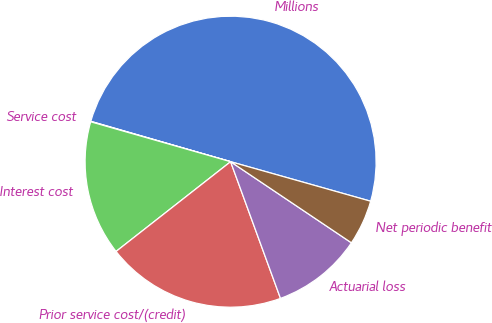<chart> <loc_0><loc_0><loc_500><loc_500><pie_chart><fcel>Millions<fcel>Service cost<fcel>Interest cost<fcel>Prior service cost/(credit)<fcel>Actuarial loss<fcel>Net periodic benefit<nl><fcel>49.9%<fcel>0.05%<fcel>15.0%<fcel>19.99%<fcel>10.02%<fcel>5.03%<nl></chart> 